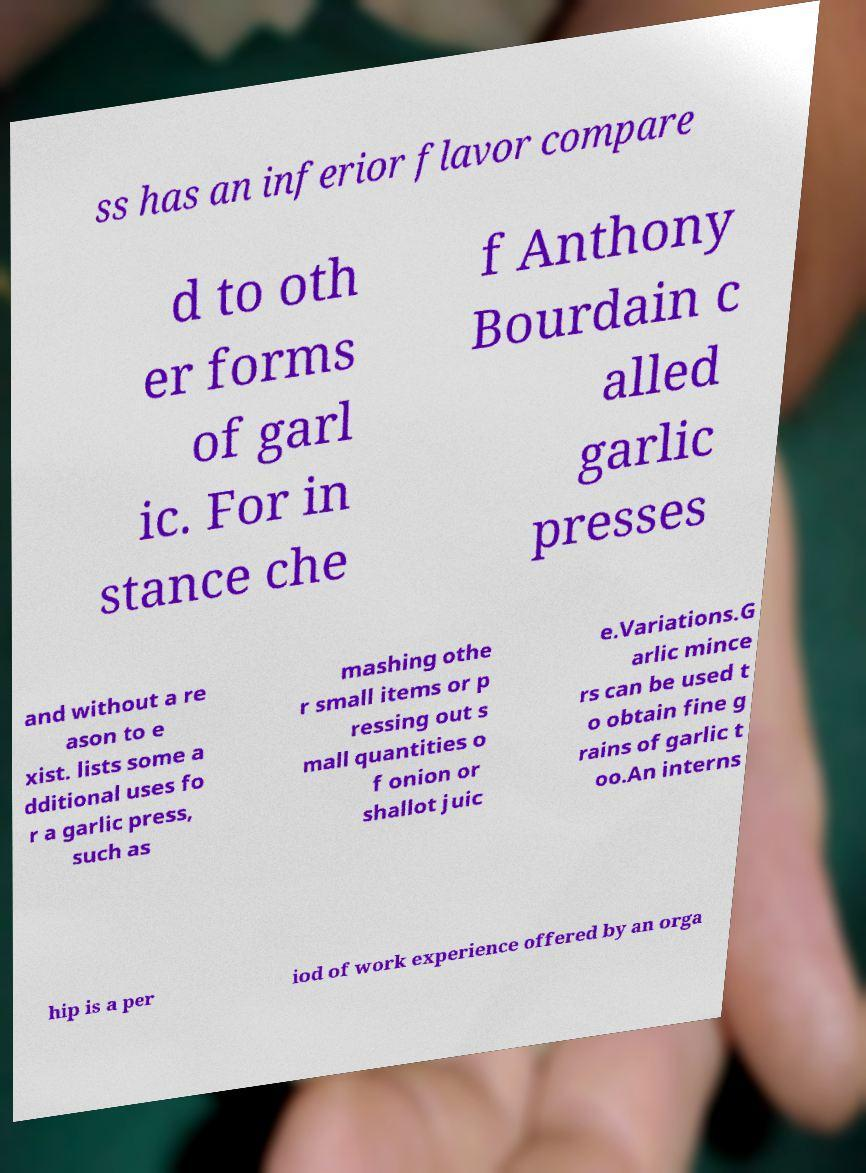Could you assist in decoding the text presented in this image and type it out clearly? ss has an inferior flavor compare d to oth er forms of garl ic. For in stance che f Anthony Bourdain c alled garlic presses and without a re ason to e xist. lists some a dditional uses fo r a garlic press, such as mashing othe r small items or p ressing out s mall quantities o f onion or shallot juic e.Variations.G arlic mince rs can be used t o obtain fine g rains of garlic t oo.An interns hip is a per iod of work experience offered by an orga 